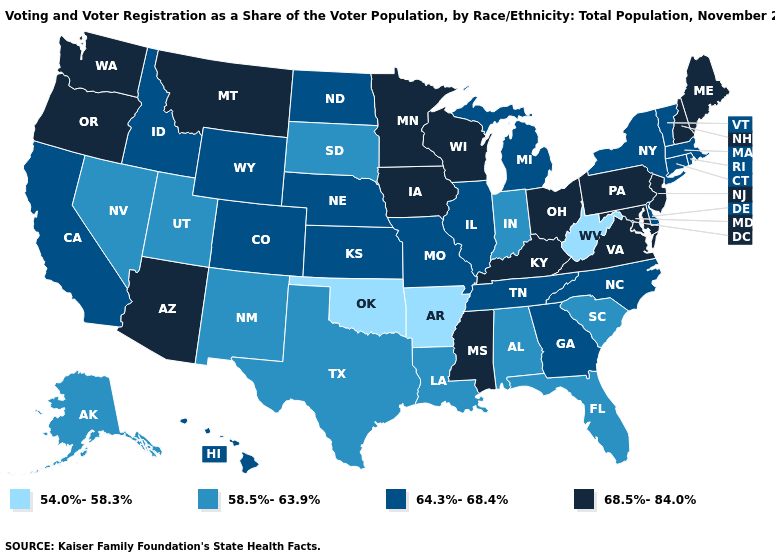Does Maryland have the highest value in the USA?
Be succinct. Yes. What is the highest value in the USA?
Answer briefly. 68.5%-84.0%. Name the states that have a value in the range 64.3%-68.4%?
Give a very brief answer. California, Colorado, Connecticut, Delaware, Georgia, Hawaii, Idaho, Illinois, Kansas, Massachusetts, Michigan, Missouri, Nebraska, New York, North Carolina, North Dakota, Rhode Island, Tennessee, Vermont, Wyoming. Does Arizona have a lower value than Georgia?
Give a very brief answer. No. What is the lowest value in states that border Maine?
Be succinct. 68.5%-84.0%. What is the value of Wyoming?
Concise answer only. 64.3%-68.4%. What is the value of West Virginia?
Concise answer only. 54.0%-58.3%. Among the states that border North Dakota , does South Dakota have the lowest value?
Answer briefly. Yes. Among the states that border Vermont , which have the lowest value?
Be succinct. Massachusetts, New York. Among the states that border Georgia , which have the lowest value?
Concise answer only. Alabama, Florida, South Carolina. Name the states that have a value in the range 58.5%-63.9%?
Concise answer only. Alabama, Alaska, Florida, Indiana, Louisiana, Nevada, New Mexico, South Carolina, South Dakota, Texas, Utah. Name the states that have a value in the range 58.5%-63.9%?
Short answer required. Alabama, Alaska, Florida, Indiana, Louisiana, Nevada, New Mexico, South Carolina, South Dakota, Texas, Utah. What is the value of Nebraska?
Concise answer only. 64.3%-68.4%. What is the highest value in the MidWest ?
Short answer required. 68.5%-84.0%. Does Hawaii have a lower value than New Jersey?
Keep it brief. Yes. 